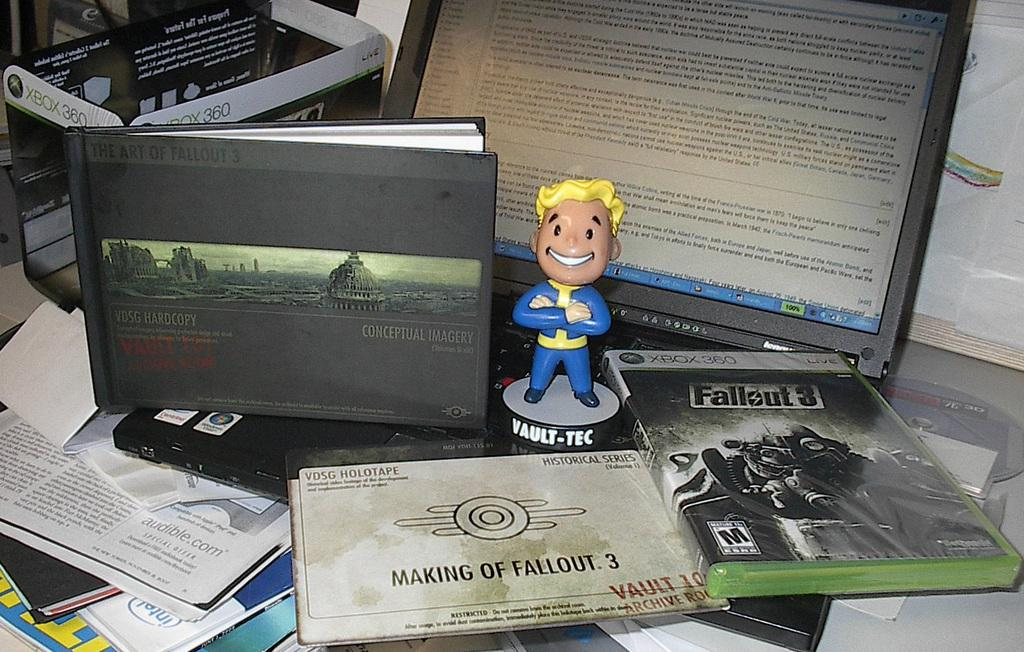<image>
Write a terse but informative summary of the picture. A toy man on a laptop keyboard along with an XBox game and a book about imagery. 